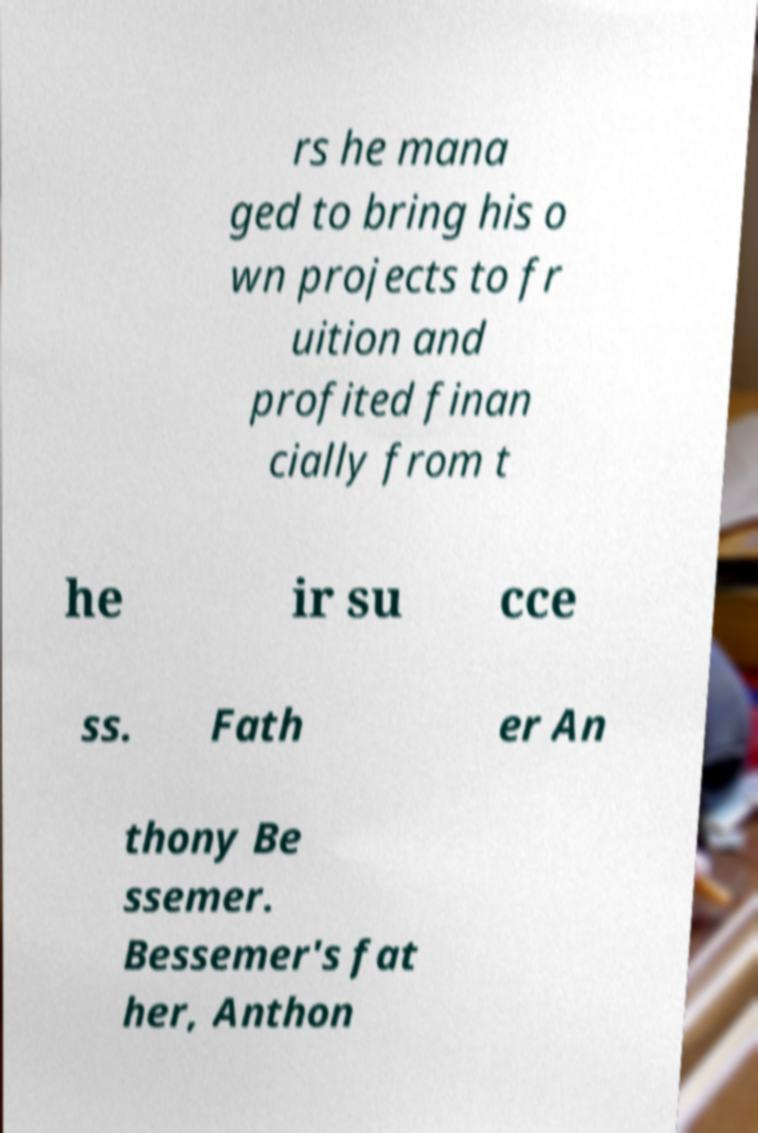For documentation purposes, I need the text within this image transcribed. Could you provide that? rs he mana ged to bring his o wn projects to fr uition and profited finan cially from t he ir su cce ss. Fath er An thony Be ssemer. Bessemer's fat her, Anthon 